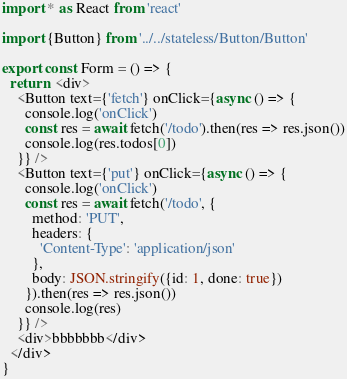Convert code to text. <code><loc_0><loc_0><loc_500><loc_500><_TypeScript_>import * as React from 'react'

import {Button} from '../../stateless/Button/Button'

export const Form = () => {
  return  <div>
    <Button text={'fetch'} onClick={async () => {
      console.log('onClick')
      const res = await fetch('/todo').then(res => res.json())
      console.log(res.todos[0])
    }} />
    <Button text={'put'} onClick={async () => {
      console.log('onClick')
      const res = await fetch('/todo', {
        method: 'PUT',
        headers: {
          'Content-Type': 'application/json'
        },
        body: JSON.stringify({id: 1, done: true})
      }).then(res => res.json())
      console.log(res)
    }} />
    <div>bbbbbbb</div>
  </div>
}</code> 